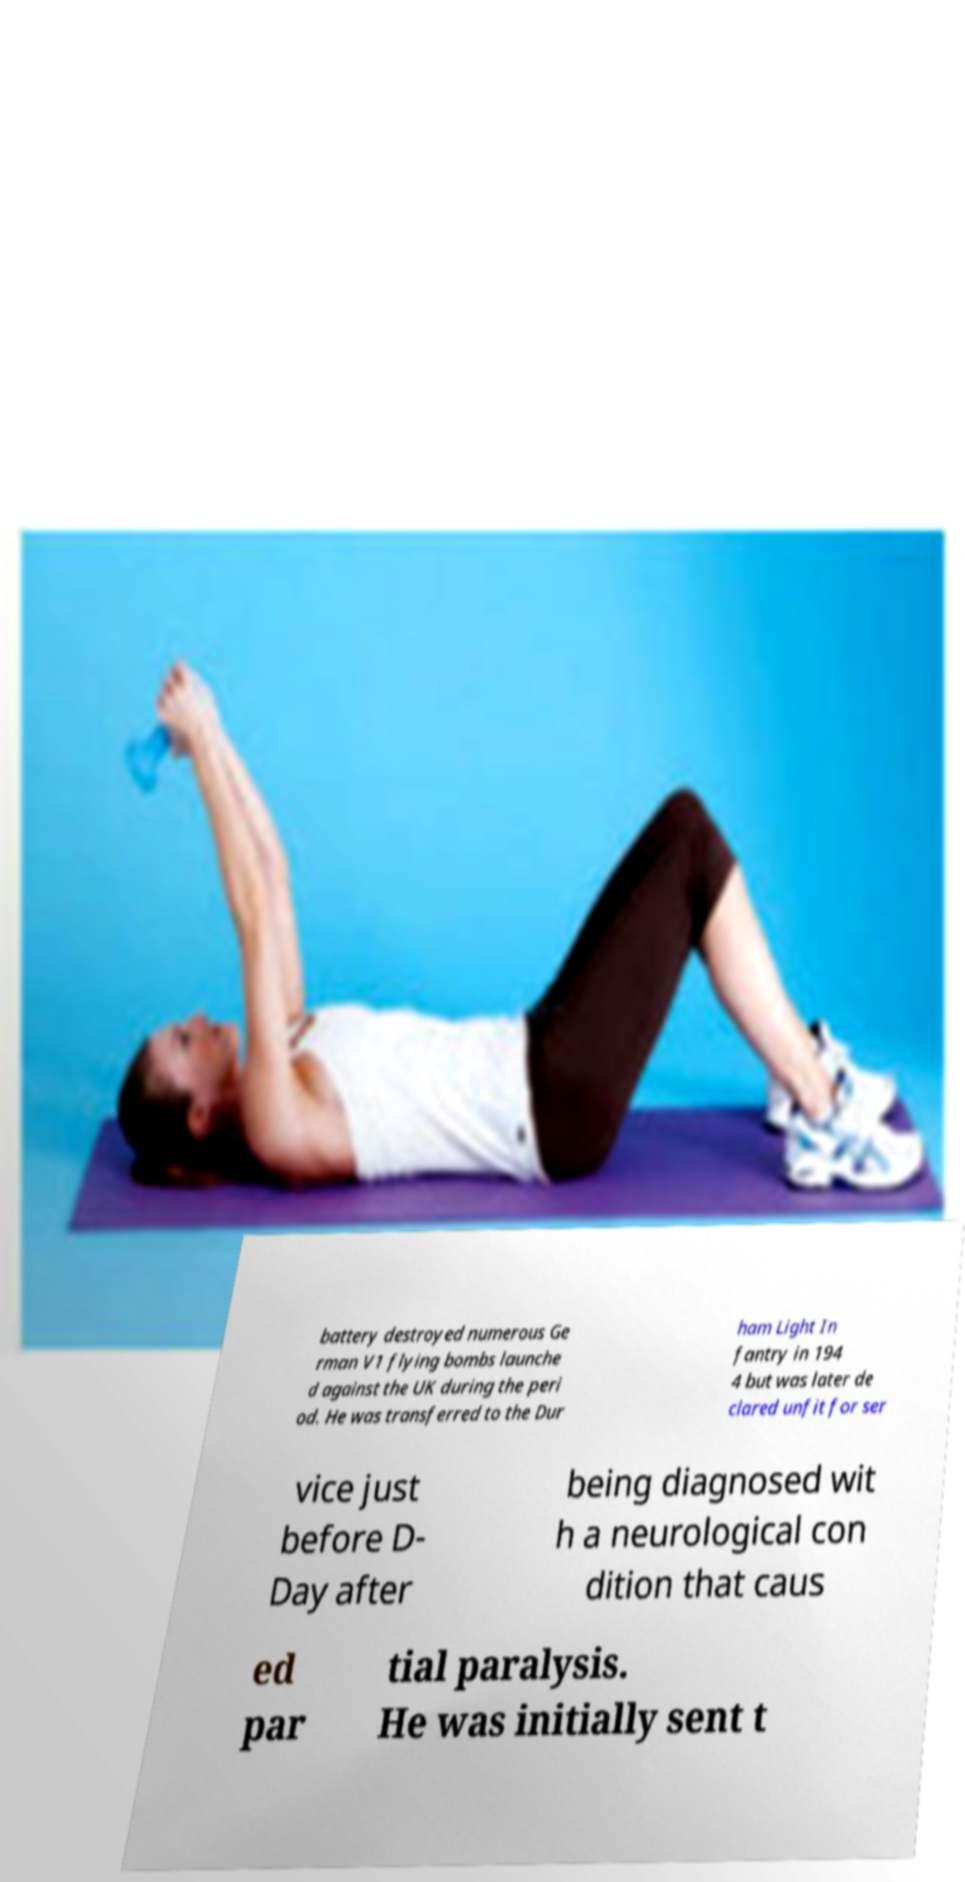Can you accurately transcribe the text from the provided image for me? battery destroyed numerous Ge rman V1 flying bombs launche d against the UK during the peri od. He was transferred to the Dur ham Light In fantry in 194 4 but was later de clared unfit for ser vice just before D- Day after being diagnosed wit h a neurological con dition that caus ed par tial paralysis. He was initially sent t 